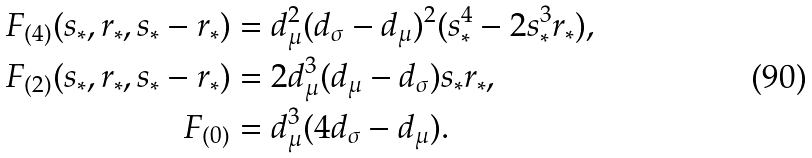Convert formula to latex. <formula><loc_0><loc_0><loc_500><loc_500>F _ { ( 4 ) } ( s _ { \ast } , r _ { \ast } , s _ { \ast } - r _ { \ast } ) & = d _ { \mu } ^ { 2 } ( d _ { \sigma } - d _ { \mu } ) ^ { 2 } ( s _ { \ast } ^ { 4 } - 2 s _ { \ast } ^ { 3 } r _ { \ast } ) , \\ F _ { ( 2 ) } ( s _ { \ast } , r _ { \ast } , s _ { \ast } - r _ { \ast } ) & = 2 d _ { \mu } ^ { 3 } ( d _ { \mu } - d _ { \sigma } ) s _ { \ast } r _ { \ast } , \\ F _ { ( 0 ) } & = d _ { \mu } ^ { 3 } ( 4 d _ { \sigma } - d _ { \mu } ) .</formula> 